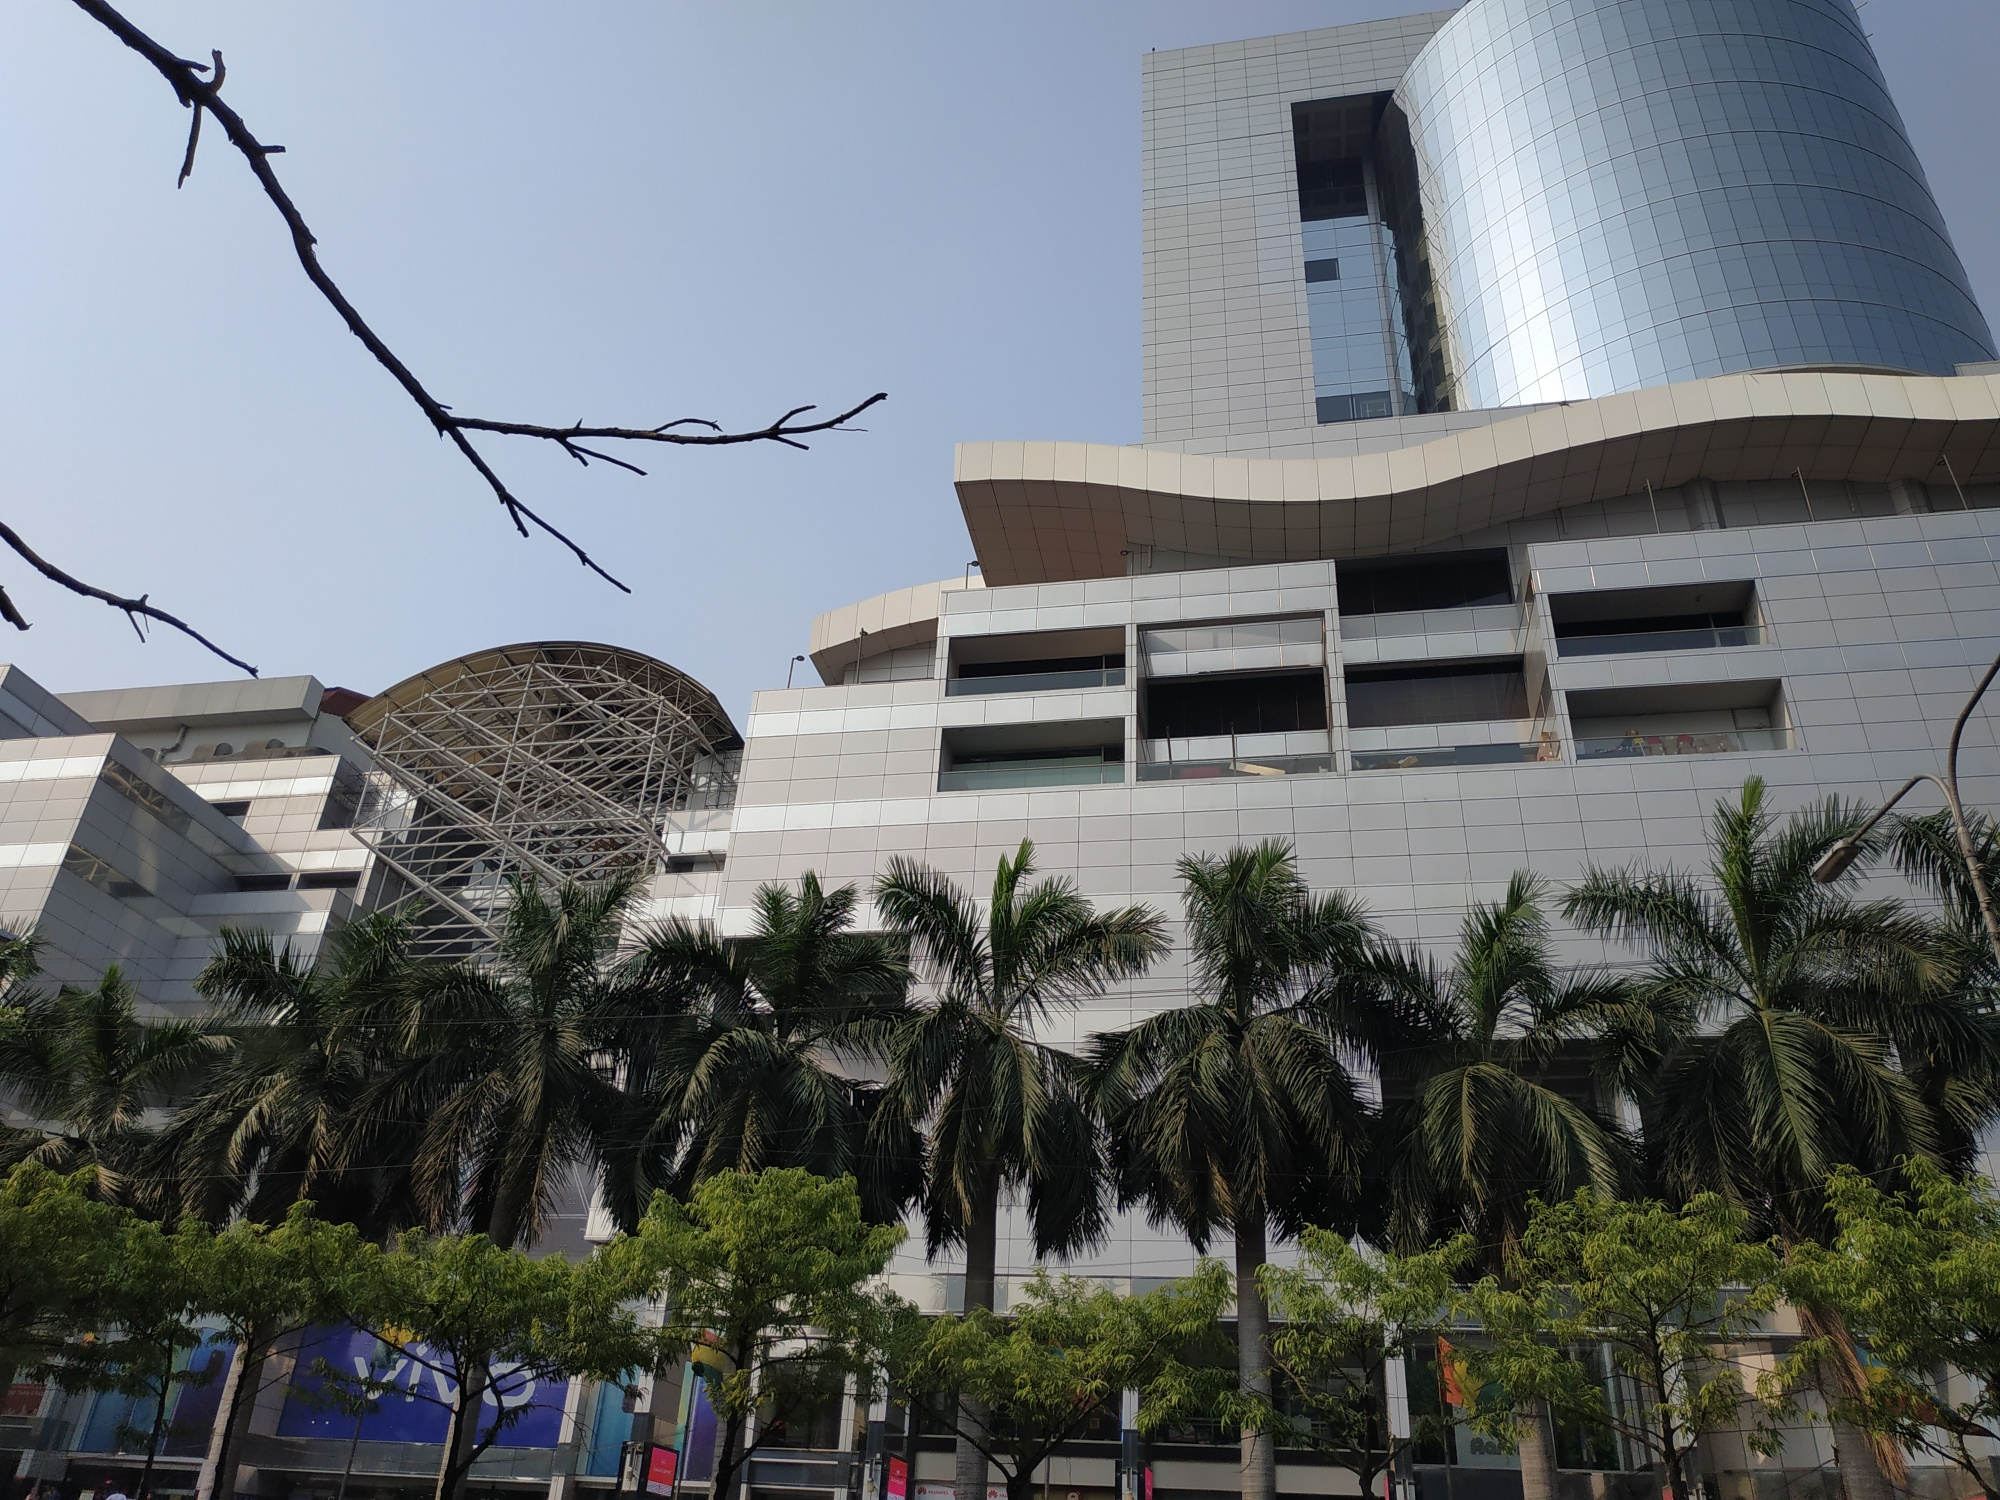Can you describe a day in the life of someone working in one of the top floors of this building? Imagine starting your day inside one of the top floors of this magnificent building. As you step into the office, you're greeted with floor-to-ceiling windows offering breathtaking views of the cityscape, the sunlight streaming in and creating a vibrant workspace. The bustling city beneath seems a world apart from the serene and sophisticated office environment. Your day begins with a morning coffee, savoring the peaceful moment before diving into important meetings and collaborative sessions held in sleek, modern conference rooms. The advanced infrastructure of the building ensures seamless connectivity and comfort, making every task efficient and enjoyable. During breaks, you might take a moment to relax, looking out at the panoramic view of the city, marveling at the combination of urban hustle and natural beauty. As the day ends, the setting sun casts a warm glow over the landscape, providing a perfect backdrop for winding down and reflecting on a productive day. 